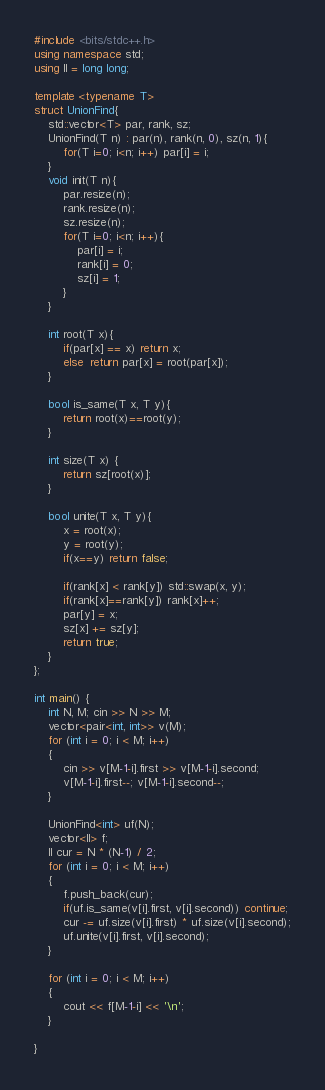<code> <loc_0><loc_0><loc_500><loc_500><_C++_>#include <bits/stdc++.h>
using namespace std;
using ll = long long;

template <typename T>
struct UnionFind{
    std::vector<T> par, rank, sz;
    UnionFind(T n) : par(n), rank(n, 0), sz(n, 1){
        for(T i=0; i<n; i++) par[i] = i;
    }
    void init(T n){
        par.resize(n);
        rank.resize(n);
        sz.resize(n);
        for(T i=0; i<n; i++){
            par[i] = i;
            rank[i] = 0;
            sz[i] = 1;
        }
    }
    
    int root(T x){
        if(par[x] == x) return x;
        else  return par[x] = root(par[x]);
    }
    
    bool is_same(T x, T y){
        return root(x)==root(y);
    }
    
    int size(T x) {
        return sz[root(x)];
    }
    
    bool unite(T x, T y){
        x = root(x);
        y = root(y);
        if(x==y) return false;
        
        if(rank[x] < rank[y]) std::swap(x, y);
        if(rank[x]==rank[y]) rank[x]++;
        par[y] = x;
        sz[x] += sz[y];
        return true;
    }
};

int main() {
    int N, M; cin >> N >> M;
    vector<pair<int, int>> v(M);
    for (int i = 0; i < M; i++)
    {
        cin >> v[M-1-i].first >> v[M-1-i].second;
        v[M-1-i].first--; v[M-1-i].second--;
    }

    UnionFind<int> uf(N);
    vector<ll> f;
    ll cur = N * (N-1) / 2;
    for (int i = 0; i < M; i++)
    {
        f.push_back(cur);
        if(uf.is_same(v[i].first, v[i].second)) continue;
        cur -= uf.size(v[i].first) * uf.size(v[i].second);
        uf.unite(v[i].first, v[i].second);
    }

    for (int i = 0; i < M; i++)
    {
        cout << f[M-1-i] << '\n'; 
    }
    
}</code> 